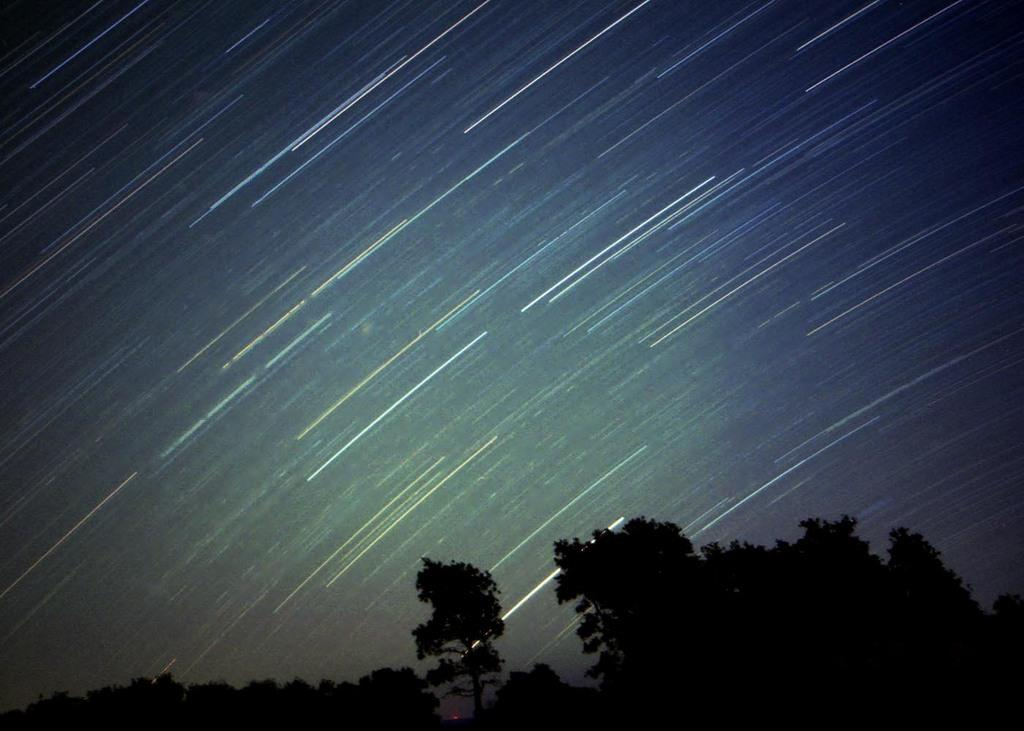What type of vegetation can be seen in the image? There are many trees in the image. What part of the natural environment is visible in the image? The sky is visible in the image. What celestial objects can be seen in the image? Stars are present in the image. How many brothers are depicted in the image? There are no people, including brothers, present in the image. What type of jelly can be seen in the image? There is no jelly present in the image. 